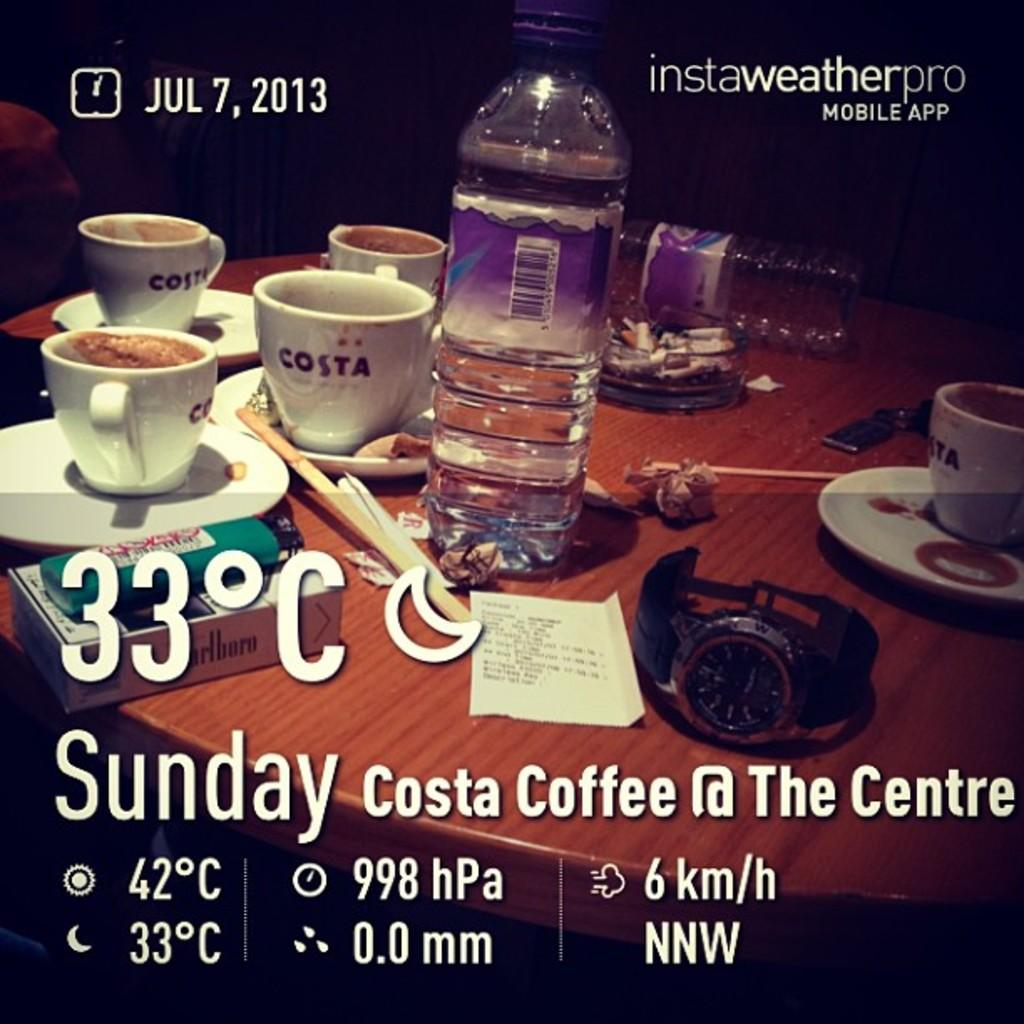<image>
Summarize the visual content of the image. A temperature of 33 degrees celsius is advertised as well as Costa Coffee. 